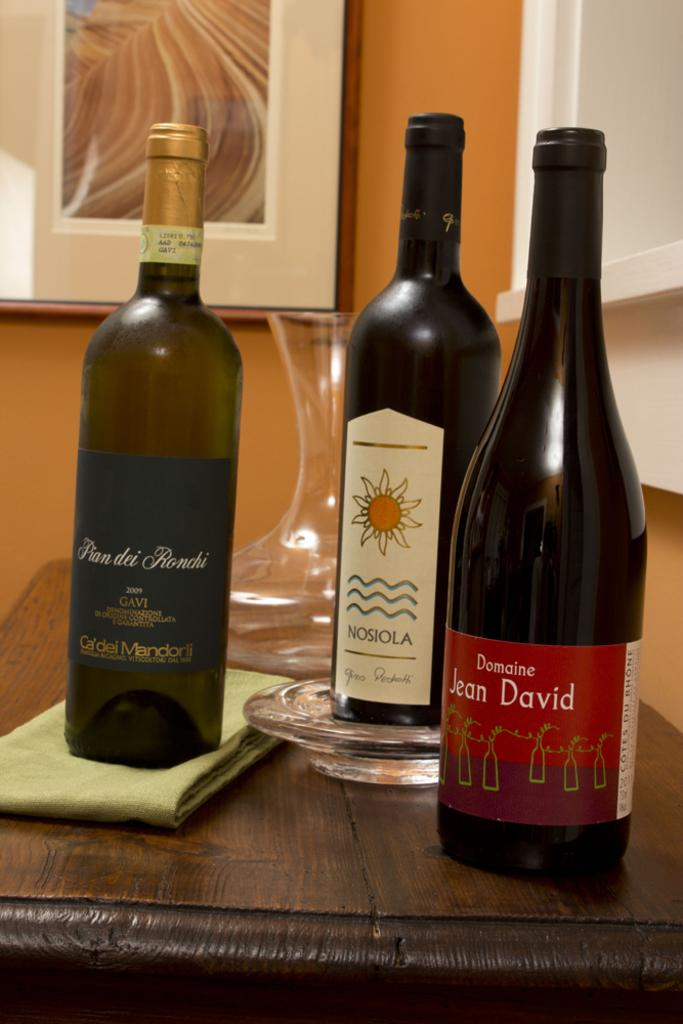<image>
Share a concise interpretation of the image provided. a bottle of wine that has the name David on it 